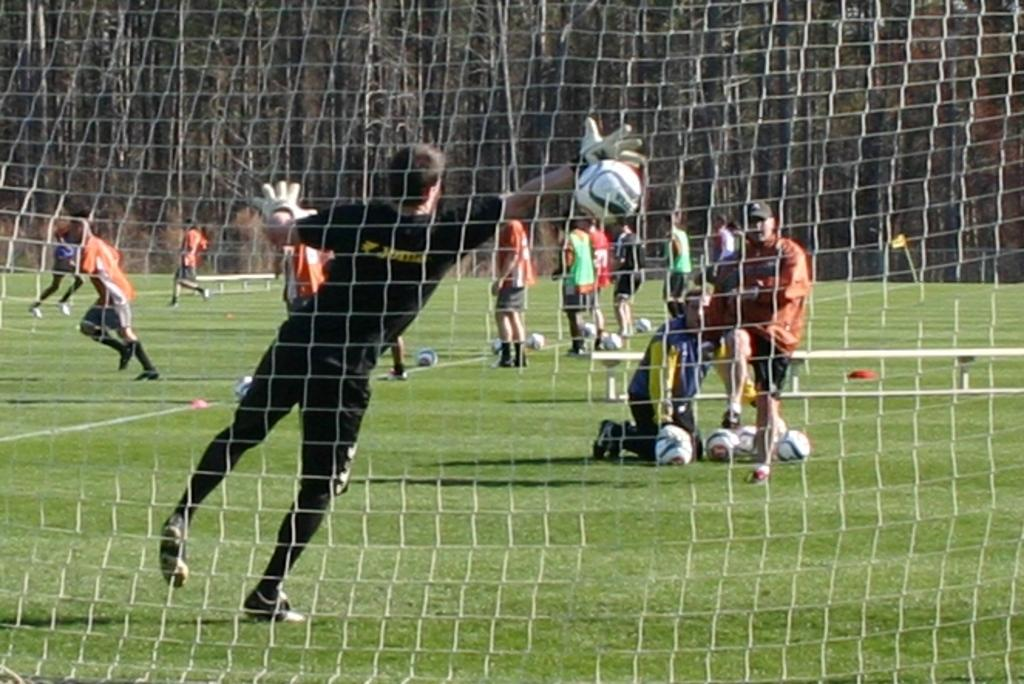What is the person in the image doing? The person is playing with a ball. Are there any other people in the image? Yes, there is a group of persons standing nearby. What might be the purpose of the net in the image? The net could be used for a game or sport, such as volleyball or tennis. What time of day is it in the image, and is there a rainstorm happening? The time of day and weather conditions are not mentioned in the image, so we cannot determine if it is afternoon or if there is a rainstorm happening. 